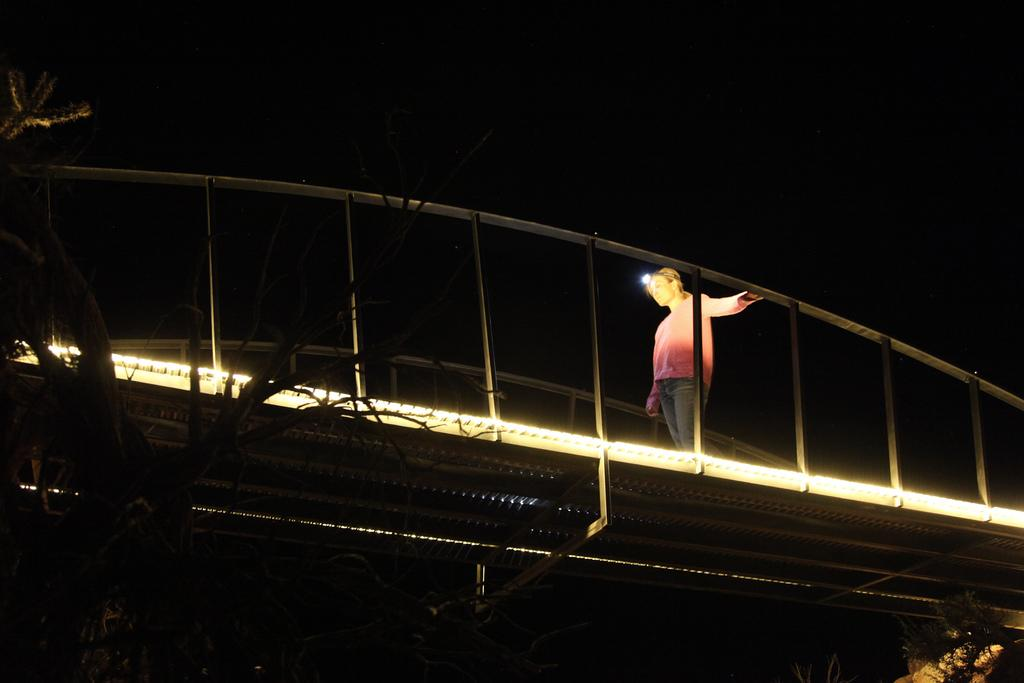What is the main subject of the image? There is a person walking on a bridge in the image. What type of structure is present in the image? There is a bridge in the image. What other natural element can be seen in the image? There is a tree in the image. How would you describe the lighting in the image? The background of the image is dark. What type of lipstick is the person wearing in the image? There is no indication of the person wearing lipstick or any makeup in the image. Can you describe the curtain hanging near the tree in the image? There is no curtain present in the image; it only features a person walking on a bridge, a bridge, a tree, and a dark background. 